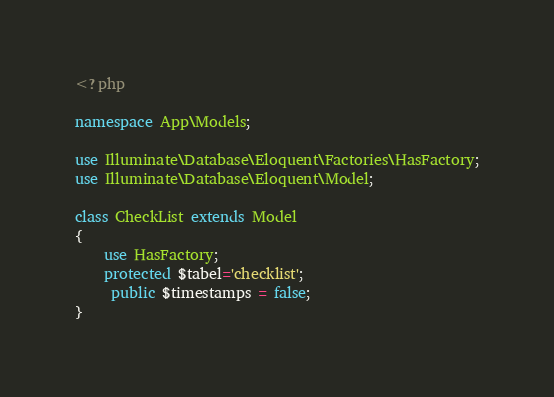<code> <loc_0><loc_0><loc_500><loc_500><_PHP_><?php

namespace App\Models;

use Illuminate\Database\Eloquent\Factories\HasFactory;
use Illuminate\Database\Eloquent\Model;

class CheckList extends Model
{
    use HasFactory;
    protected $tabel='checklist';
	 public $timestamps = false;
}
</code> 